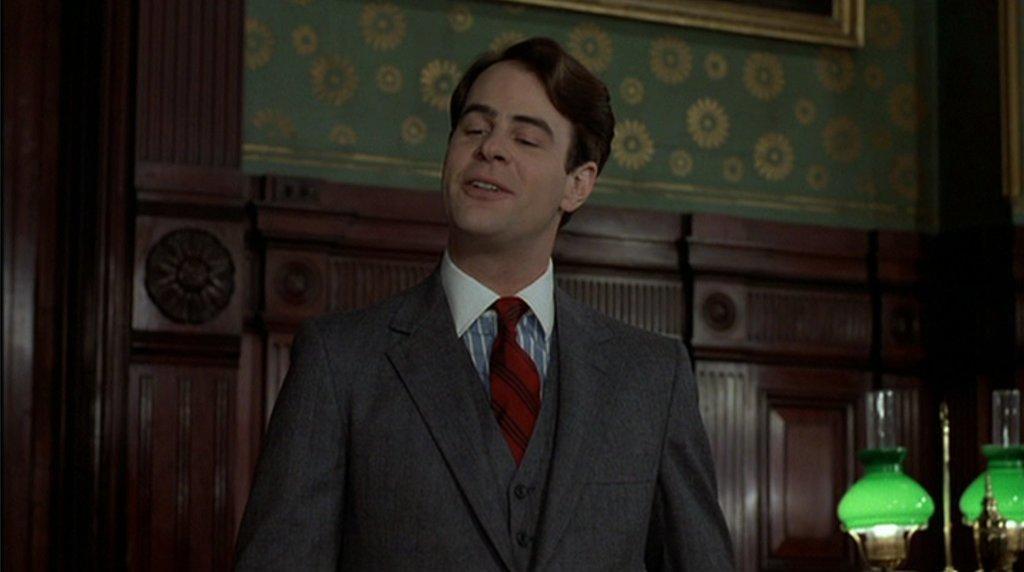Please provide a concise description of this image. In this picture we can see a person,he is smiling and in the background we can see some objects. 